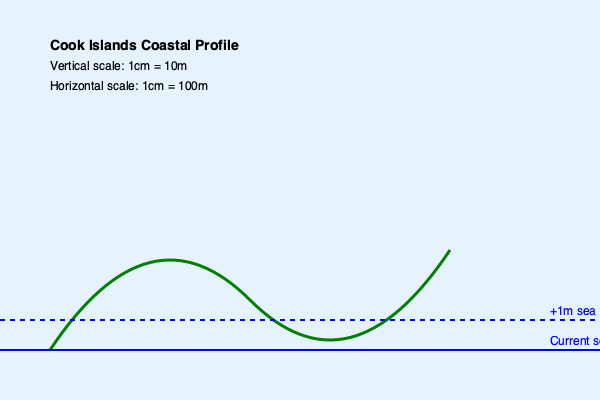Based on the topographic map of a Cook Islands coastline, calculate the percentage of land area that would be submerged if sea levels rise by 1 meter. Assume the coastal profile extends inland for 5 km with a similar topography. To solve this problem, we need to follow these steps:

1. Analyze the topographic map:
   - The current sea level is at y = 350 pixels
   - The projected 1m sea level rise is at y = 320 pixels
   - The difference of 30 pixels represents 1m in elevation

2. Calculate the vertical scale:
   - 30 pixels = 1m
   - 1 pixel = 1/30 m = 0.0333m

3. Determine the submerged area on the graph:
   - Estimate the area between the current coastline and the new coastline
   - This area is approximately a triangle with:
     Base (b) ≈ 100 pixels
     Height (h) ≈ 30 pixels

4. Calculate the submerged area:
   Area = $\frac{1}{2} \times b \times h$
   Area = $\frac{1}{2} \times 100 \times 30 = 1500$ square pixels

5. Convert pixel area to real-world area:
   - Horizontal scale: 1cm = 100m, so 1 pixel = 100m / 600 = 0.1667m
   - Area in m² = 1500 × (0.1667m)² = 41.675m²

6. Extrapolate to 5km inland:
   - 5km = 5000m
   - Ratio of graph width to 5km: 5000m / (600 × 0.1667m) = 50
   - Total submerged area = 41.675m² × 50 = 2083.75m²

7. Calculate total land area:
   Total area = 5000m × 100m = 500,000m²

8. Calculate percentage of submerged land:
   Percentage = (Submerged area / Total area) × 100
   = (2083.75 / 500,000) × 100 = 0.41675%
Answer: 0.42% of land area submerged 